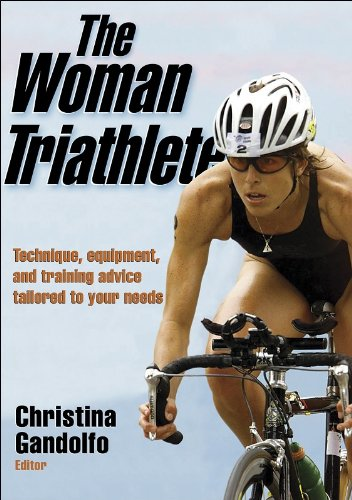Who is the author of this book? The book, 'The Woman Triathlete', lists Christina Gandolfo as the editor. She plays a key role in compiling and overseeing the content which includes technique, equipment, and training advice specifically catered to female triathletes. 